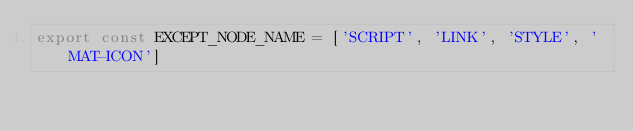Convert code to text. <code><loc_0><loc_0><loc_500><loc_500><_TypeScript_>export const EXCEPT_NODE_NAME = ['SCRIPT', 'LINK', 'STYLE', 'MAT-ICON']</code> 